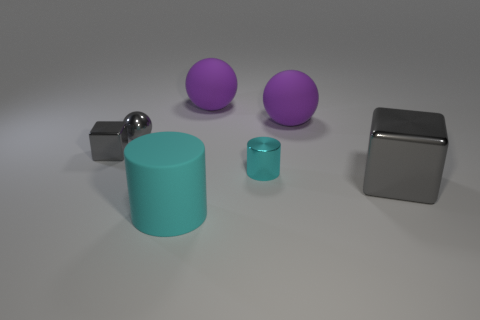How many small objects have the same shape as the large gray metallic object?
Your answer should be compact. 1. Do the metallic ball and the shiny cylinder have the same color?
Provide a short and direct response. No. Is there anything else that has the same shape as the cyan rubber thing?
Give a very brief answer. Yes. Are there any matte balls of the same color as the small metallic ball?
Keep it short and to the point. No. Do the cylinder right of the big cyan cylinder and the gray thing that is to the right of the tiny metal cylinder have the same material?
Your answer should be compact. Yes. What color is the tiny metallic block?
Give a very brief answer. Gray. What is the size of the cyan cylinder that is behind the big rubber thing in front of the gray metal cube on the right side of the tiny ball?
Your answer should be very brief. Small. How many other things are there of the same size as the gray ball?
Offer a very short reply. 2. What number of big cubes have the same material as the tiny gray sphere?
Ensure brevity in your answer.  1. What is the shape of the small metallic thing that is on the right side of the large cyan thing?
Your answer should be very brief. Cylinder. 